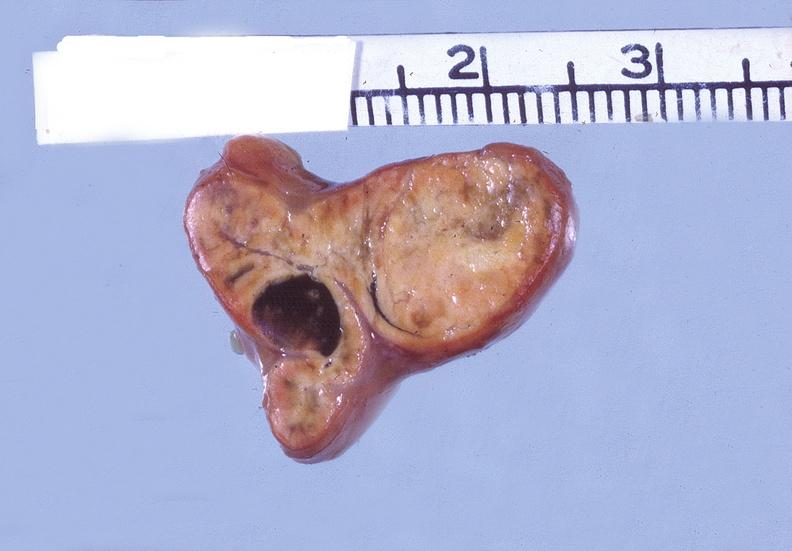does this image show adrenal, cortical adenoma?
Answer the question using a single word or phrase. Yes 